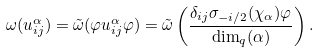Convert formula to latex. <formula><loc_0><loc_0><loc_500><loc_500>\omega ( u _ { i j } ^ { \alpha } ) = \tilde { \omega } ( \varphi u _ { i j } ^ { \alpha } \varphi ) = \tilde { \omega } \left ( \frac { \delta _ { i j } \sigma _ { - i / 2 } ( \chi _ { \alpha } ) \varphi } { \dim _ { q } ( \alpha ) } \right ) .</formula> 